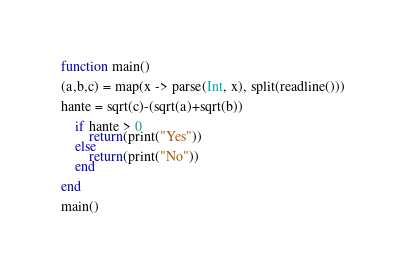<code> <loc_0><loc_0><loc_500><loc_500><_Julia_>function main()

(a,b,c) = map(x -> parse(Int, x), split(readline()))

hante = sqrt(c)-(sqrt(a)+sqrt(b)) 
    
    if hante > 0
        return(print("Yes"))
    else
        return(print("No"))
    end

end

main()</code> 